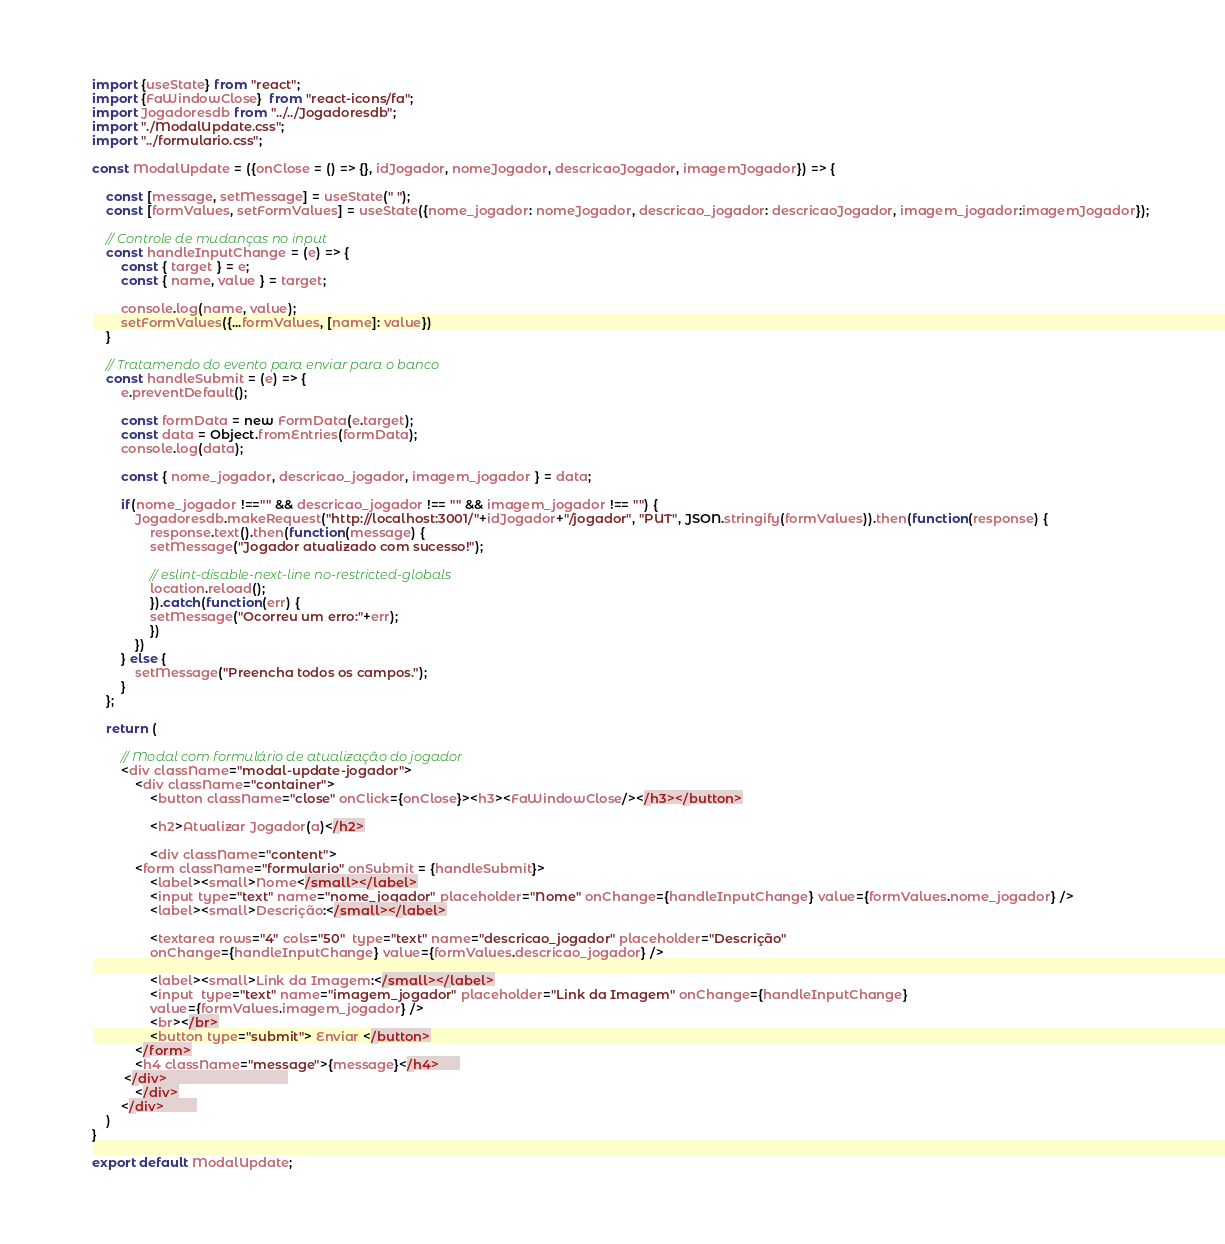Convert code to text. <code><loc_0><loc_0><loc_500><loc_500><_JavaScript_>import {useState} from "react";
import {FaWindowClose}  from "react-icons/fa";
import Jogadoresdb from "../../Jogadoresdb";
import "./ModalUpdate.css";
import "../formulario.css";

const ModalUpdate = ({onClose = () => {}, idJogador, nomeJogador, descricaoJogador, imagemJogador}) => {

    const [message, setMessage] = useState(" ");
    const [formValues, setFormValues] = useState({nome_jogador: nomeJogador, descricao_jogador: descricaoJogador, imagem_jogador:imagemJogador});

    // Controle de mudanças no input
    const handleInputChange = (e) => {
        const { target } = e;
        const { name, value } = target;

        console.log(name, value);
        setFormValues({...formValues, [name]: value})
    }

    // Tratamendo do evento para enviar para o banco
    const handleSubmit = (e) => {
        e.preventDefault();

        const formData = new FormData(e.target);
        const data = Object.fromEntries(formData);
        console.log(data);
        
        const { nome_jogador, descricao_jogador, imagem_jogador } = data;

        if(nome_jogador !=="" && descricao_jogador !== "" && imagem_jogador !== "") {
            Jogadoresdb.makeRequest("http://localhost:3001/"+idJogador+"/jogador", "PUT", JSON.stringify(formValues)).then(function(response) {
                response.text().then(function(message) {
                setMessage("Jogador atualizado com sucesso!");

                // eslint-disable-next-line no-restricted-globals
                location.reload();
                }).catch(function(err) {
                setMessage("Ocorreu um erro:"+err);
                })
            })
        } else {
            setMessage("Preencha todos os campos.");
        }        
    };    

    return (

        // Modal com formulário de atualização do jogador
        <div className="modal-update-jogador">
            <div className="container">
                <button className="close" onClick={onClose}><h3><FaWindowClose/></h3></button>

                <h2>Atualizar Jogador(a)</h2>

                <div className="content">                      
            <form className="formulario" onSubmit = {handleSubmit}>
                <label><small>Nome</small></label>
                <input type="text" name="nome_jogador" placeholder="Nome" onChange={handleInputChange} value={formValues.nome_jogador} />
                <label><small>Descrição:</small></label>

                <textarea rows="4" cols="50"  type="text" name="descricao_jogador" placeholder="Descrição" 
                onChange={handleInputChange} value={formValues.descricao_jogador} />

                <label><small>Link da Imagem:</small></label>
                <input  type="text" name="imagem_jogador" placeholder="Link da Imagem" onChange={handleInputChange} 
                value={formValues.imagem_jogador} />
                <br></br>
                <button type="submit"> Enviar </button>
            </form>
            <h4 className="message">{message}</h4>     
         </div>                              
            </div>
        </div>        
    )
}

export default ModalUpdate;
</code> 